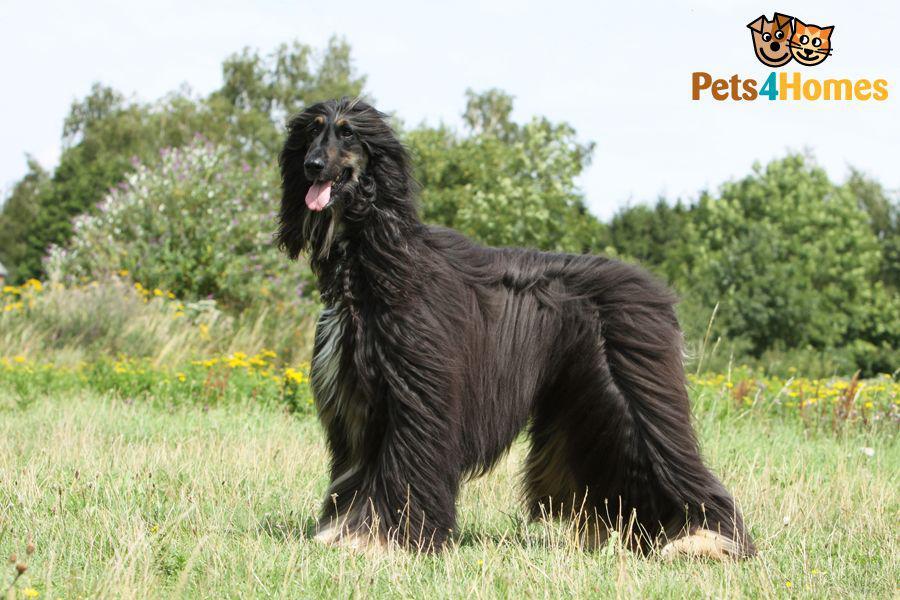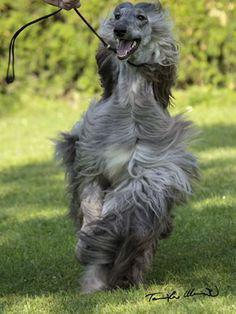The first image is the image on the left, the second image is the image on the right. Analyze the images presented: Is the assertion "One image shows a mostly black dog sitting upright in the grass." valid? Answer yes or no. No. The first image is the image on the left, the second image is the image on the right. Examine the images to the left and right. Is the description "In 1 image, 1 dog is standing to the left in grass." accurate? Answer yes or no. Yes. 